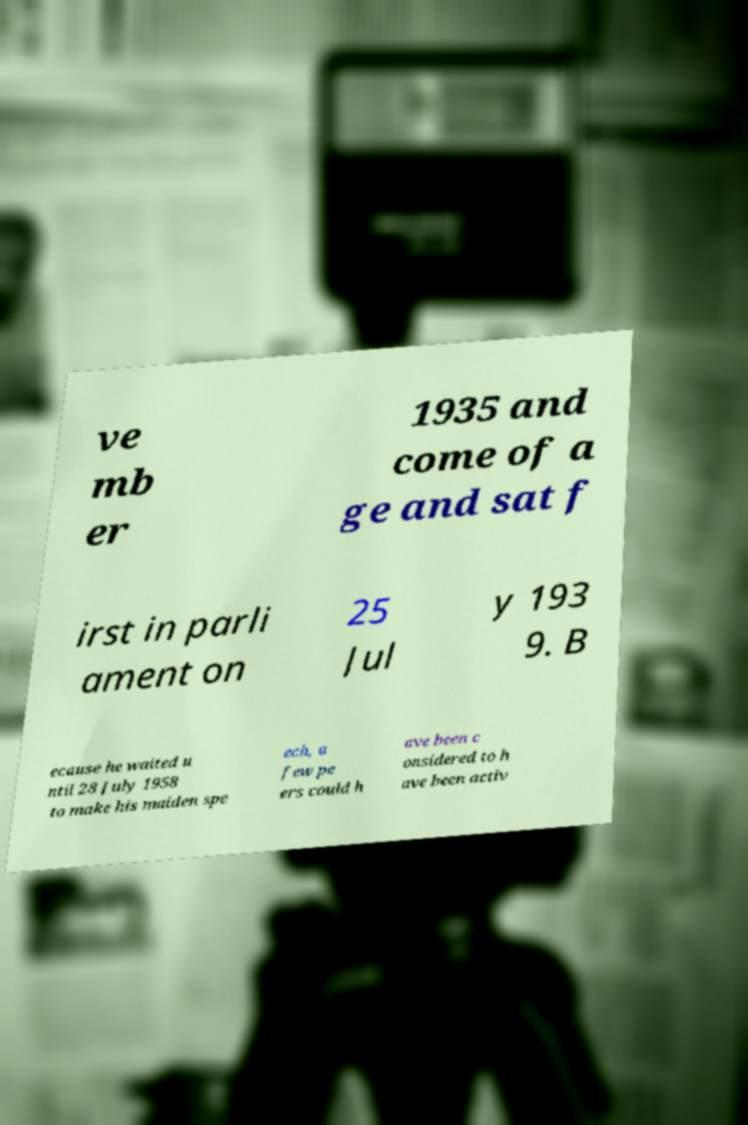What messages or text are displayed in this image? I need them in a readable, typed format. ve mb er 1935 and come of a ge and sat f irst in parli ament on 25 Jul y 193 9. B ecause he waited u ntil 28 July 1958 to make his maiden spe ech, a few pe ers could h ave been c onsidered to h ave been activ 